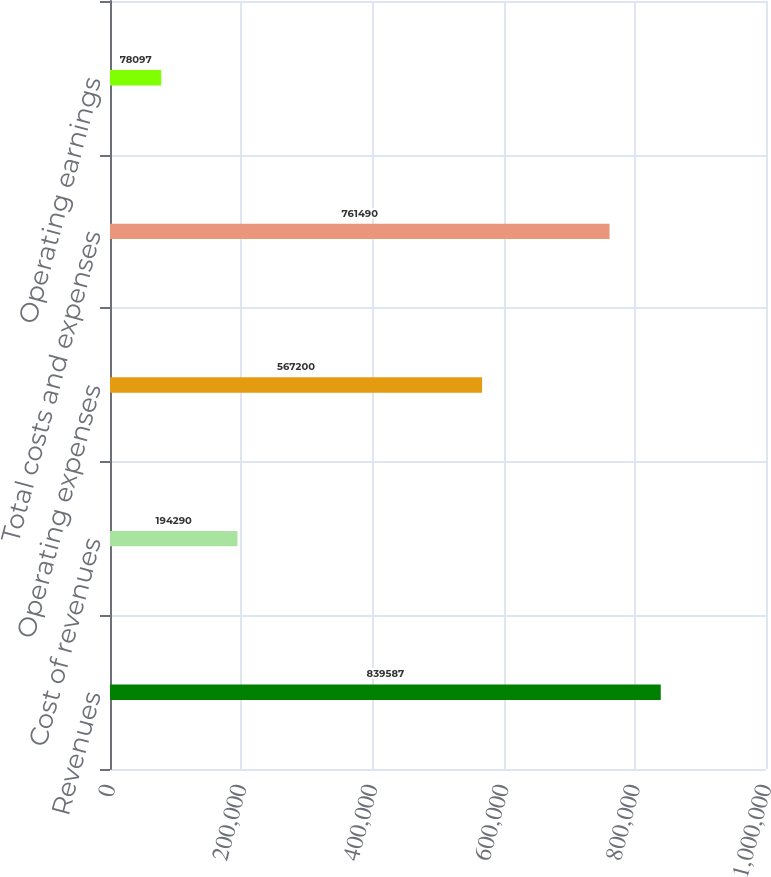Convert chart. <chart><loc_0><loc_0><loc_500><loc_500><bar_chart><fcel>Revenues<fcel>Cost of revenues<fcel>Operating expenses<fcel>Total costs and expenses<fcel>Operating earnings<nl><fcel>839587<fcel>194290<fcel>567200<fcel>761490<fcel>78097<nl></chart> 